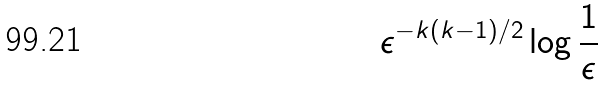Convert formula to latex. <formula><loc_0><loc_0><loc_500><loc_500>\epsilon ^ { - k ( k - 1 ) / 2 } \log \frac { 1 } { \epsilon }</formula> 